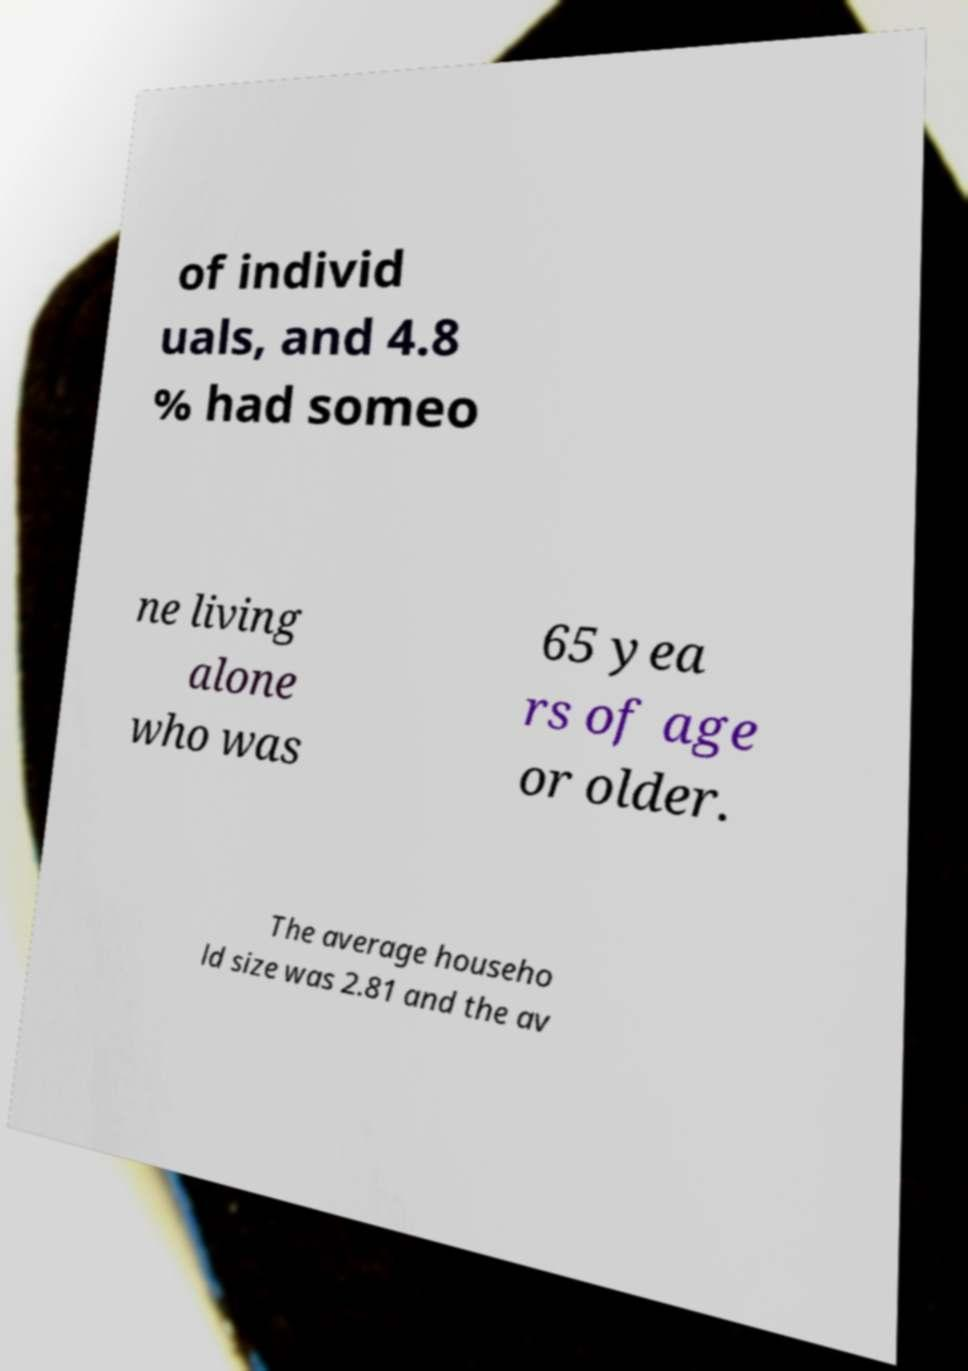Can you read and provide the text displayed in the image?This photo seems to have some interesting text. Can you extract and type it out for me? of individ uals, and 4.8 % had someo ne living alone who was 65 yea rs of age or older. The average househo ld size was 2.81 and the av 